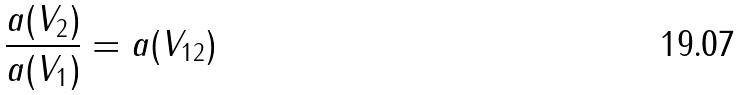<formula> <loc_0><loc_0><loc_500><loc_500>\frac { a ( V _ { 2 } ) } { a ( V _ { 1 } ) } = a ( V _ { 1 2 } )</formula> 